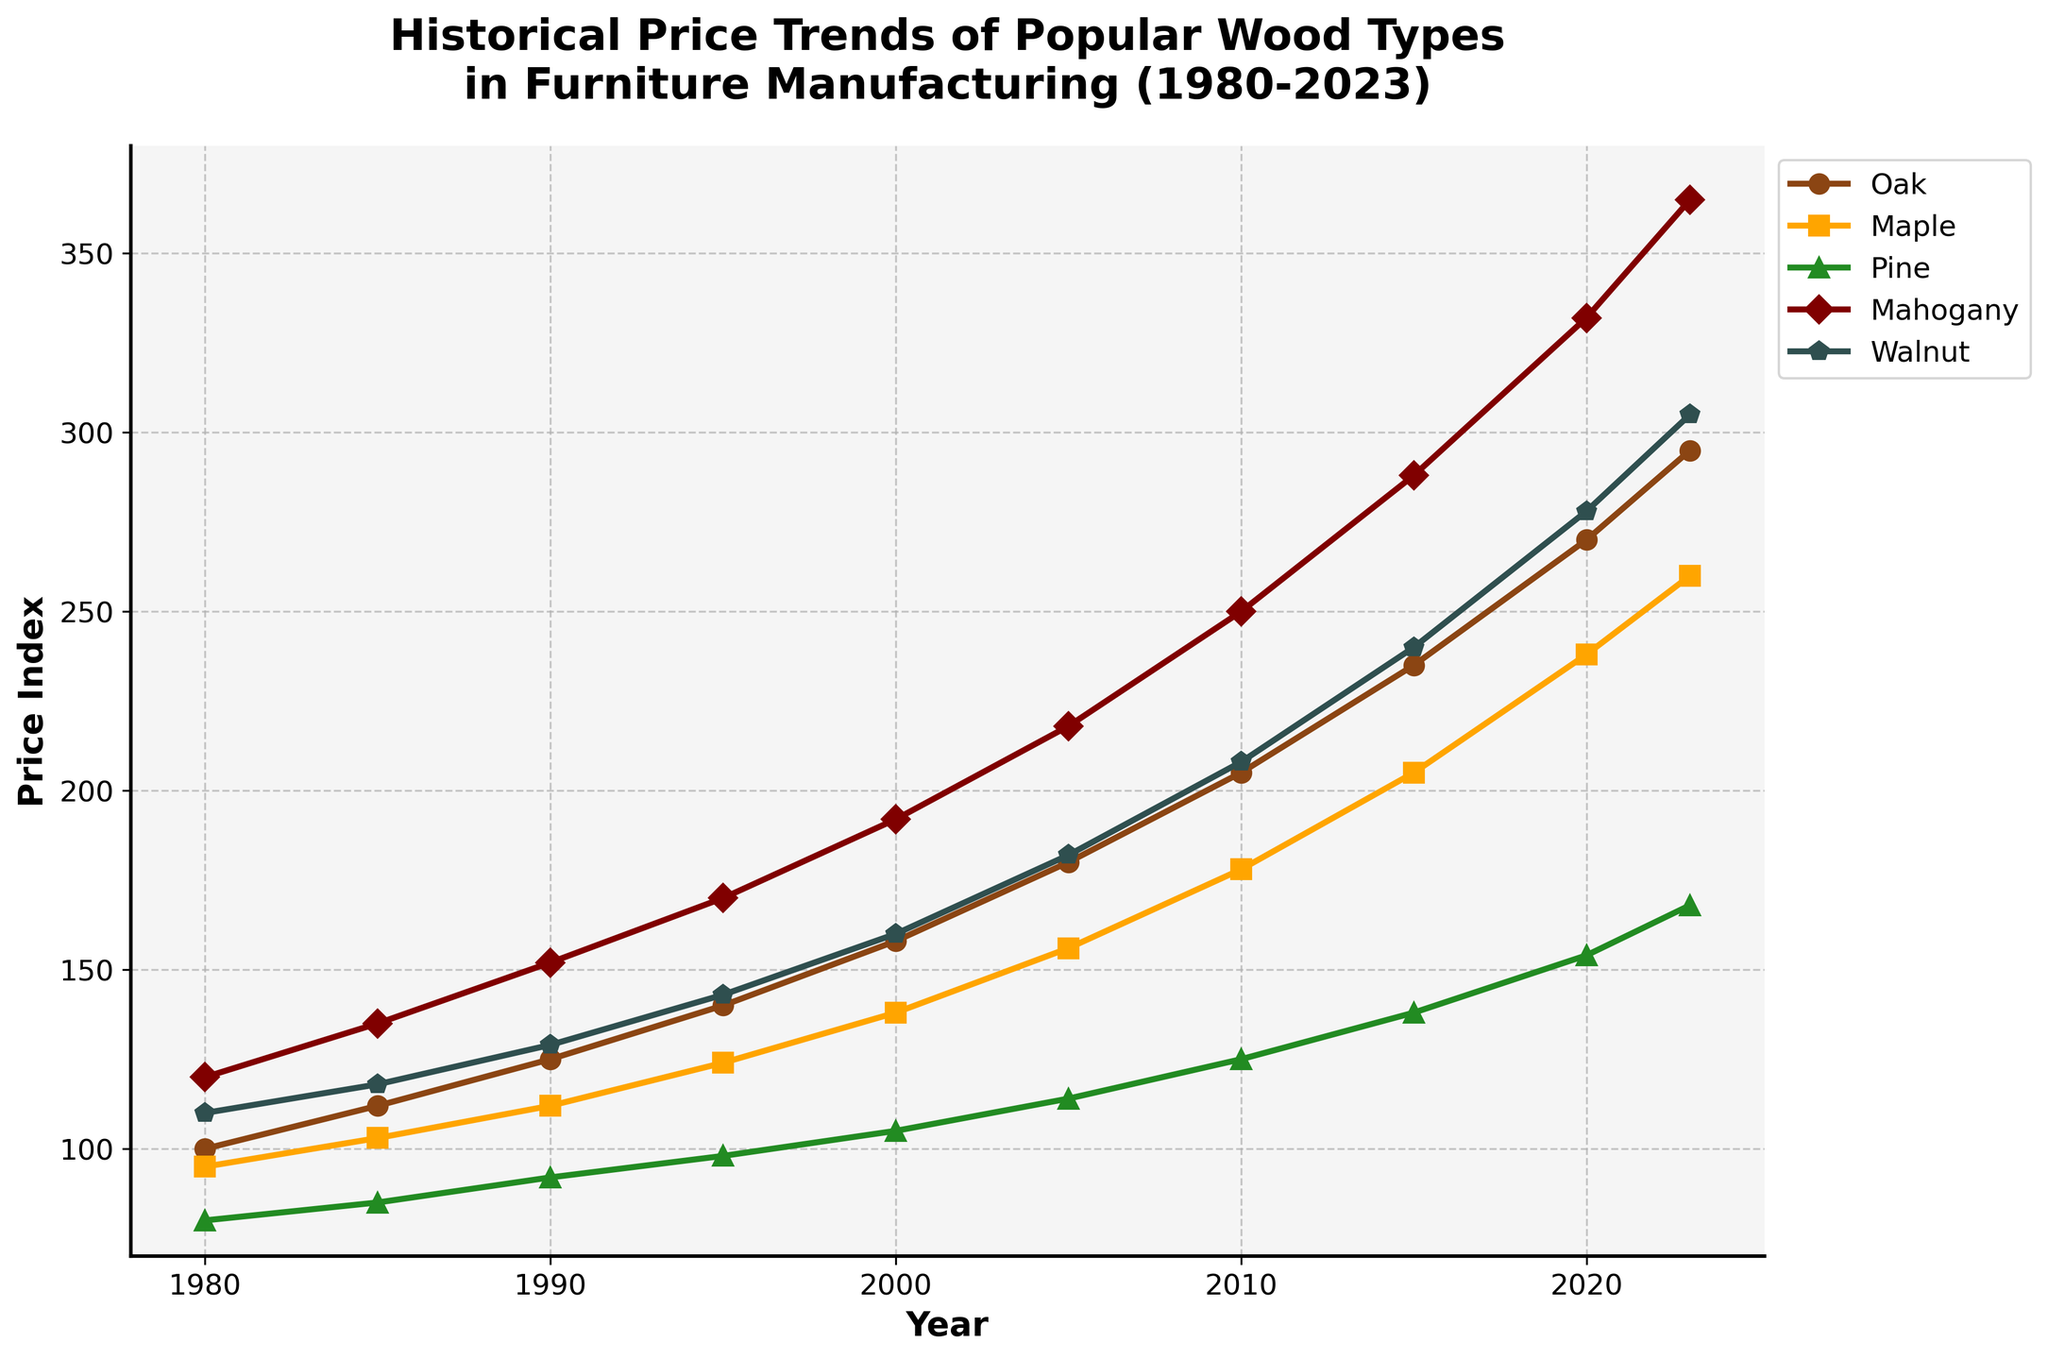What was the price of Mahogany in 2023? To find this, look at the 'Mahogany' line in 2023 on the x-axis. The y-axis value for 'Mahogany' in 2023 is 365 dollars.
Answer: 365 Which wood type saw the highest price increase from 1980 to 2023? To determine this, compare the price differences for all wood types between 1980 and 2023. Mahogany increased from 120 to 365, an increase of 245, which is the highest amongst all wood types.
Answer: Mahogany In which year did Oak surpass the 200 price index? To find this, locate when the 'Oak' line crosses the 200 mark on the y-axis. Oak surpassed 200 in 2010.
Answer: 2010 Compare the prices of Oak and Maple in 2020. Which one was higher and by how much? Look at the y-axis values for both Oak and Maple in 2020. Oak was priced at 270, and Maple at 238. The difference is 270 - 238 = 32 dollars, with Oak being higher.
Answer: Oak, 32 dollars What are the price trends of Walnut and Pine over the years? Observe the overall trends of the 'Walnut' and 'Pine' lines. Both lines show a steady upward trend, indicating continuous price increases over the years, but Walnut's increase is much steeper than Pine's.
Answer: Both increasing, Walnut steeper During which period did Maple experience the least price growth? By comparing the price increase over each interval for Maple, the smallest increase is from 1995 to 2000 (124 to 138, which is 14).
Answer: 1995 to 2000 What's the sum of prices of all wood types in the year 1995? Sum up the prices of all wood types in 1995: Oak (140), Maple (124), Pine (98), Mahogany (170), and Walnut (143). The total is 140 + 124 + 98 + 170 + 143 = 675.
Answer: 675 By how much did the price of Pine increase between 1980 and 2023? Subtract Pine's price in 1980 from its price in 2023: 168 - 80 = 88 dollars.
Answer: 88 Which wood type had the smallest price in 1985, and what was it? In 1985, Pine had the smallest price at 85 dollars.
Answer: Pine, 85 Identify a period where all wood types' prices increased. Looking at the plot, from 2015 to 2020, all lines show an upward trend, indicating that all wood types' prices increased during this period.
Answer: 2015 to 2020 